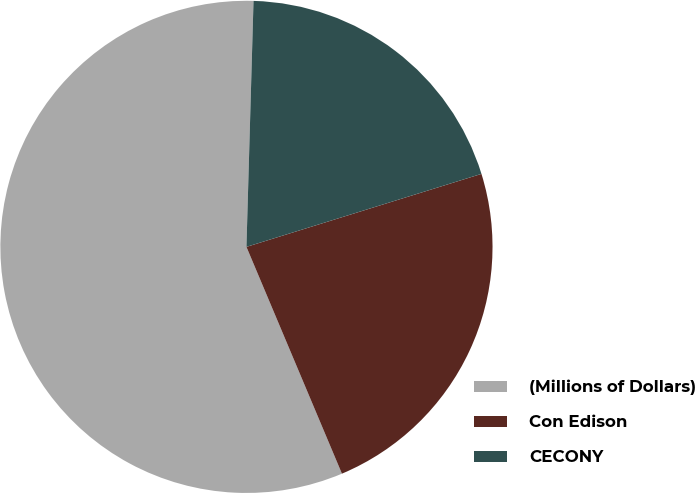<chart> <loc_0><loc_0><loc_500><loc_500><pie_chart><fcel>(Millions of Dollars)<fcel>Con Edison<fcel>CECONY<nl><fcel>56.8%<fcel>23.45%<fcel>19.75%<nl></chart> 